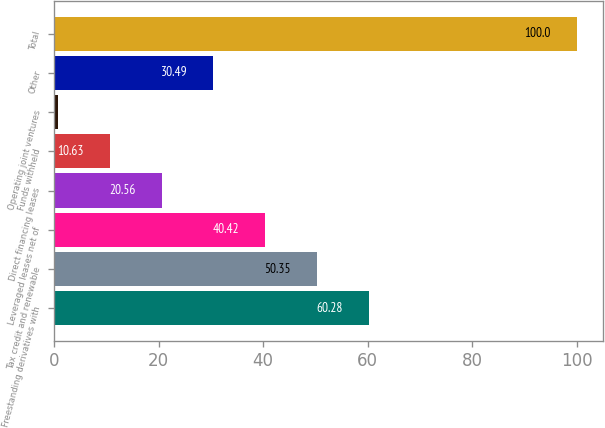<chart> <loc_0><loc_0><loc_500><loc_500><bar_chart><fcel>Freestanding derivatives with<fcel>Tax credit and renewable<fcel>Leveraged leases net of<fcel>Direct financing leases<fcel>Funds withheld<fcel>Operating joint ventures<fcel>Other<fcel>Total<nl><fcel>60.28<fcel>50.35<fcel>40.42<fcel>20.56<fcel>10.63<fcel>0.7<fcel>30.49<fcel>100<nl></chart> 